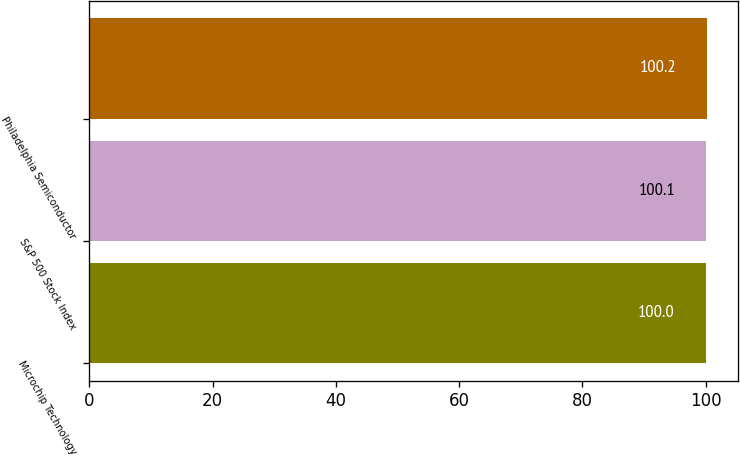Convert chart to OTSL. <chart><loc_0><loc_0><loc_500><loc_500><bar_chart><fcel>Microchip Technology<fcel>S&P 500 Stock Index<fcel>Philadelphia Semiconductor<nl><fcel>100<fcel>100.1<fcel>100.2<nl></chart> 